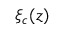<formula> <loc_0><loc_0><loc_500><loc_500>\xi _ { c } ( z )</formula> 